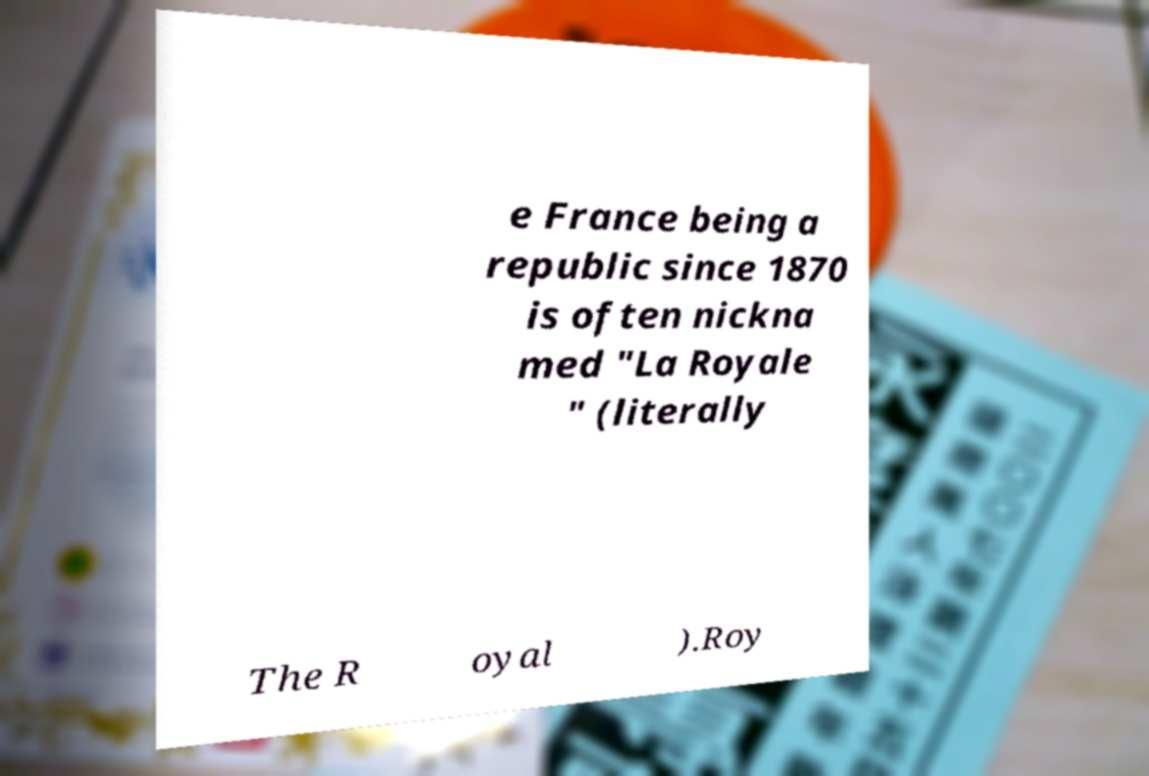Could you extract and type out the text from this image? e France being a republic since 1870 is often nickna med "La Royale " (literally The R oyal ).Roy 